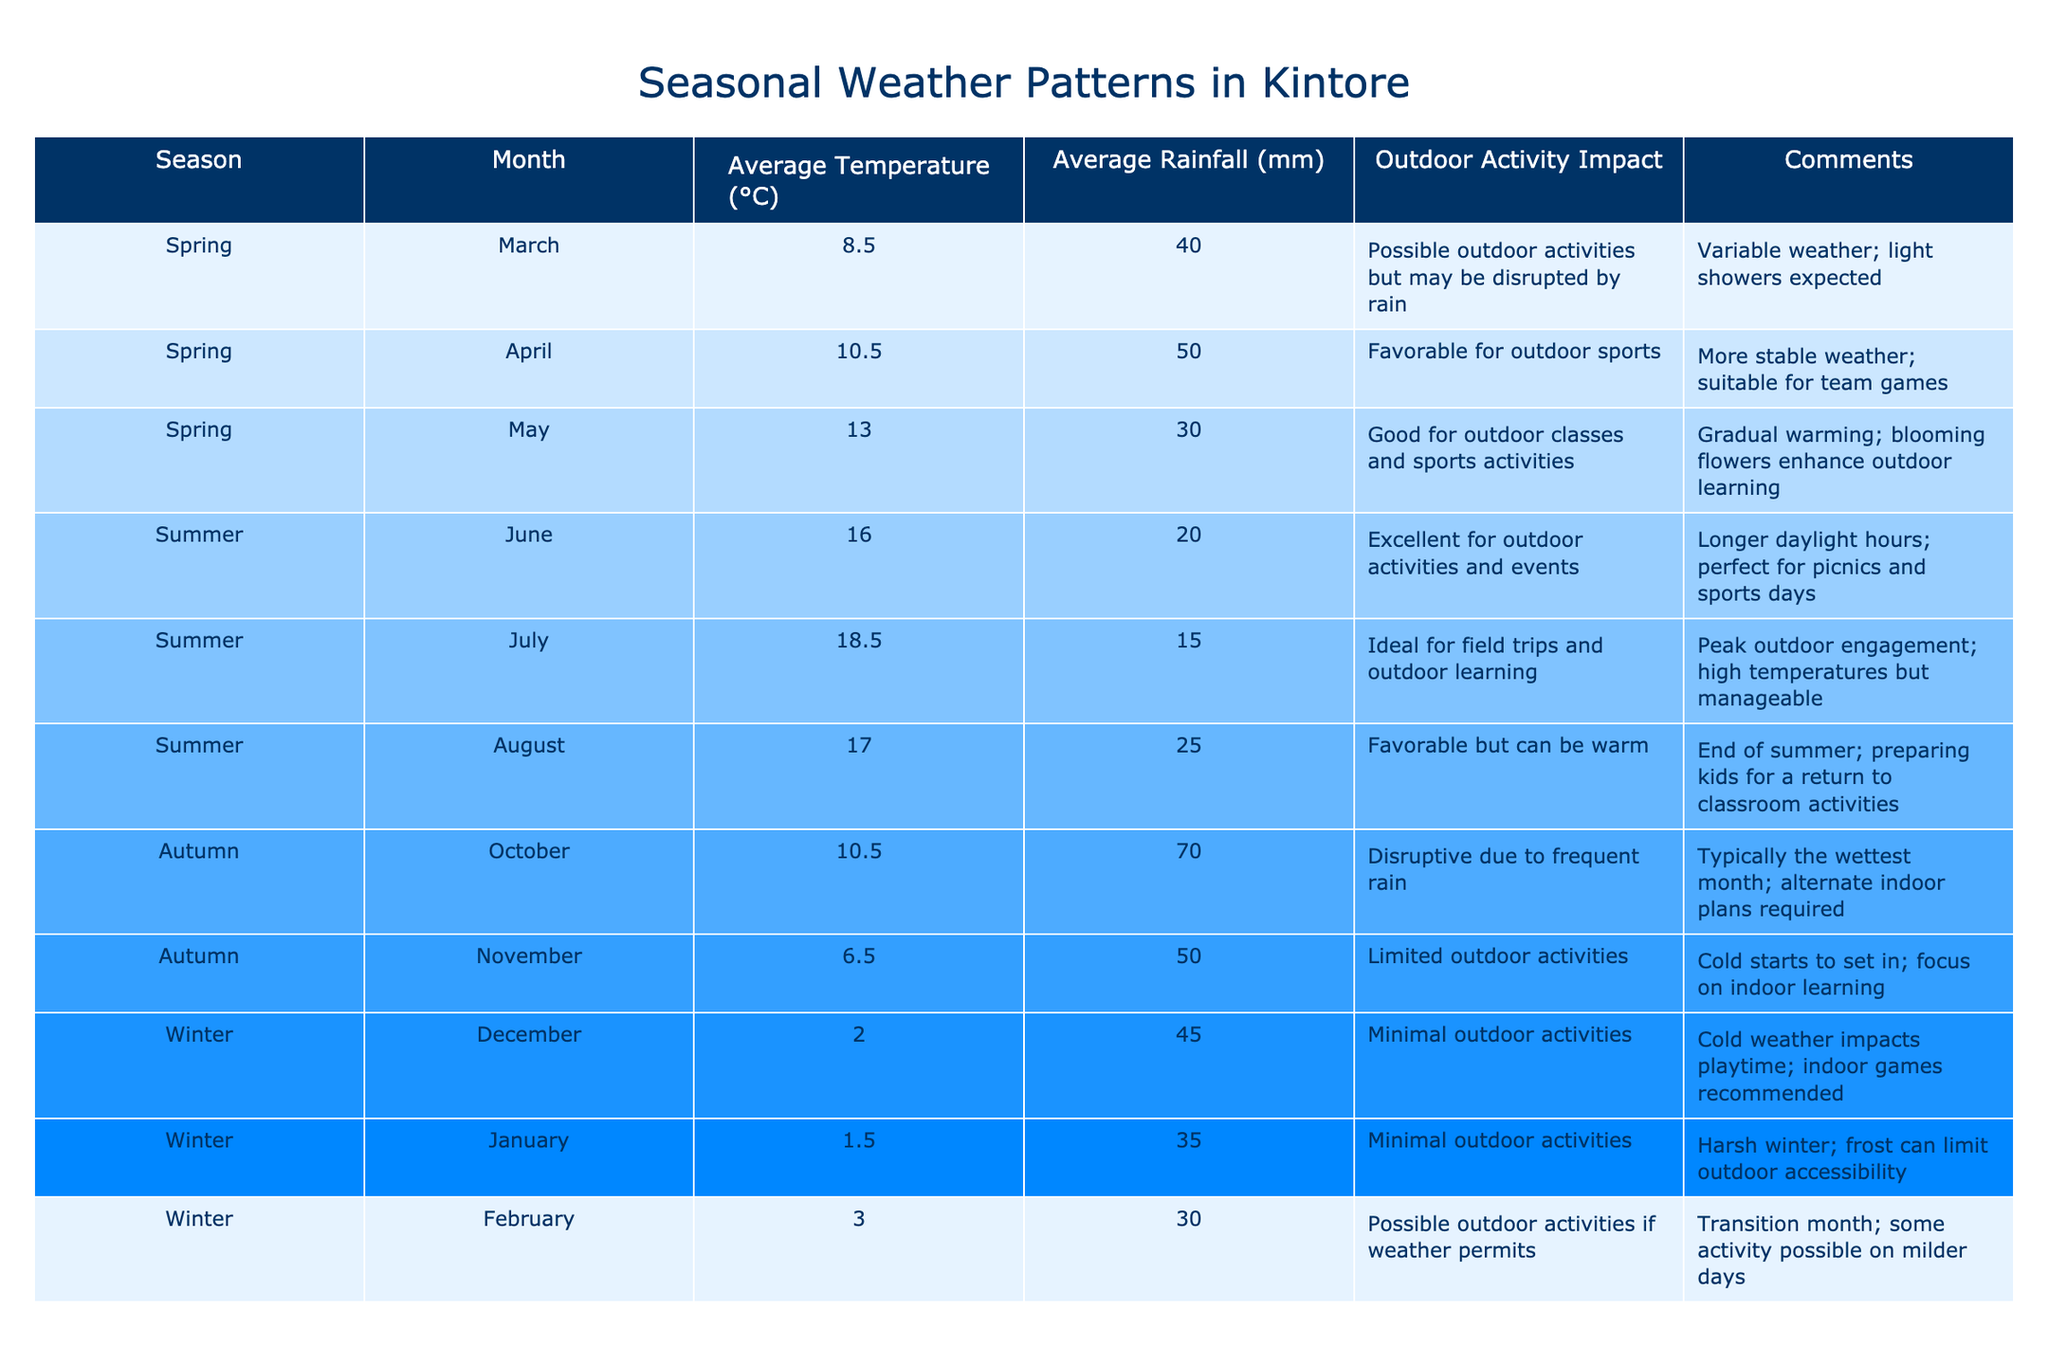What is the average temperature in July? In the table, the average temperature for July is explicitly listed under the "Average Temperature (°C)" column. The entry for July shows 18.5°C.
Answer: 18.5°C Which month has the most rainfall according to the table? The table indicates the average rainfall for each month. Upon reviewing the "Average Rainfall (mm)" column, October shows the highest value at 70mm.
Answer: October During which season are outdoor activities considered to be minimal? The "Outdoor Activity Impact" column indicates that outdoor activities are minimal in December, January, and February, which are all winter months.
Answer: Winter How does the average temperature in February compare to that in April? The average temperature in February is 3.0°C, while in April it is 10.5°C. To compare, 10.5°C - 3.0°C = 7.5°C, indicating February is 7.5°C cooler than April.
Answer: February is 7.5°C cooler than April Is outdoor learning favored in the summer months? To ascertain this, we need to review the "Outdoor Activity Impact" for June, July, and August. Each month indicates favorable or ideal conditions for outdoor activities, which supports a yes answer.
Answer: Yes What is the average rainfall for the months categorized as spring? The average rainfall for spring months (March, April, and May) needs to be calculated. March has 40mm, April 50mm, and May 30mm. This totals 40 + 50 + 30 = 120mm. Dividing by 3 gives an average of 120mm / 3 = 40mm.
Answer: 40mm During which month does the weather become favorable for outdoor sports activities? According to the table, April is identified as favorable for outdoor sports activities based on the comments provided in the "Outdoor Activity Impact" column.
Answer: April Which season has limited outdoor activities due to weather conditions? The table indicates that autumn (specifically November) has limited outdoor activities due to colder, wetter weather, leading to a focus on indoor learning as stated in the "Outdoor Activity Impact" column.
Answer: Autumn How do the average temperatures in December and January compare? The average temperature for December is 2.0°C and for January is 1.5°C. Comparing these, January is colder by calculating 2.0°C - 1.5°C = 0.5°C.
Answer: January is 0.5°C colder than December Is outdoor activity recommended in February? The "Outdoor Activity Impact" column states that activities are possible in February if the weather permits, which suggests uncertainty rather than a strong recommendation.
Answer: It depends on the weather Which season generally provides the best conditions for outdoor activities? By examining the "Outdoor Activity Impact" column across all seasons, summer consistently shows excellent or ideal conditions for outdoor activities, with comments reflecting positively on the weather.
Answer: Summer 